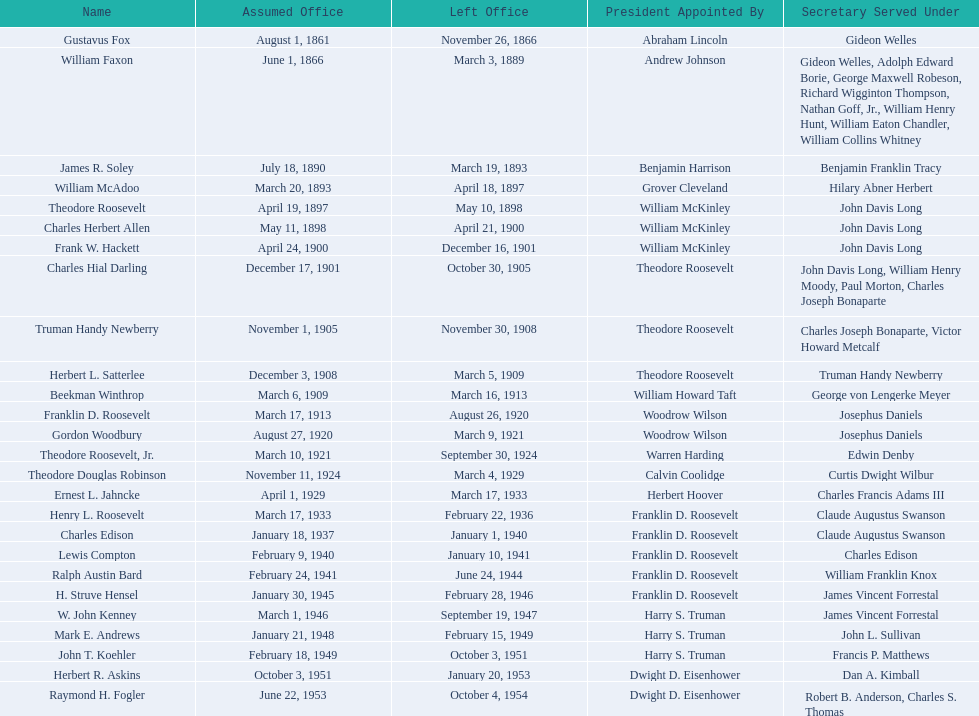Write the full table. {'header': ['Name', 'Assumed Office', 'Left Office', 'President Appointed By', 'Secretary Served Under'], 'rows': [['Gustavus Fox', 'August 1, 1861', 'November 26, 1866', 'Abraham Lincoln', 'Gideon Welles'], ['William Faxon', 'June 1, 1866', 'March 3, 1889', 'Andrew Johnson', 'Gideon Welles, Adolph Edward Borie, George Maxwell Robeson, Richard Wigginton Thompson, Nathan Goff, Jr., William Henry Hunt, William Eaton Chandler, William Collins Whitney'], ['James R. Soley', 'July 18, 1890', 'March 19, 1893', 'Benjamin Harrison', 'Benjamin Franklin Tracy'], ['William McAdoo', 'March 20, 1893', 'April 18, 1897', 'Grover Cleveland', 'Hilary Abner Herbert'], ['Theodore Roosevelt', 'April 19, 1897', 'May 10, 1898', 'William McKinley', 'John Davis Long'], ['Charles Herbert Allen', 'May 11, 1898', 'April 21, 1900', 'William McKinley', 'John Davis Long'], ['Frank W. Hackett', 'April 24, 1900', 'December 16, 1901', 'William McKinley', 'John Davis Long'], ['Charles Hial Darling', 'December 17, 1901', 'October 30, 1905', 'Theodore Roosevelt', 'John Davis Long, William Henry Moody, Paul Morton, Charles Joseph Bonaparte'], ['Truman Handy Newberry', 'November 1, 1905', 'November 30, 1908', 'Theodore Roosevelt', 'Charles Joseph Bonaparte, Victor Howard Metcalf'], ['Herbert L. Satterlee', 'December 3, 1908', 'March 5, 1909', 'Theodore Roosevelt', 'Truman Handy Newberry'], ['Beekman Winthrop', 'March 6, 1909', 'March 16, 1913', 'William Howard Taft', 'George von Lengerke Meyer'], ['Franklin D. Roosevelt', 'March 17, 1913', 'August 26, 1920', 'Woodrow Wilson', 'Josephus Daniels'], ['Gordon Woodbury', 'August 27, 1920', 'March 9, 1921', 'Woodrow Wilson', 'Josephus Daniels'], ['Theodore Roosevelt, Jr.', 'March 10, 1921', 'September 30, 1924', 'Warren Harding', 'Edwin Denby'], ['Theodore Douglas Robinson', 'November 11, 1924', 'March 4, 1929', 'Calvin Coolidge', 'Curtis Dwight Wilbur'], ['Ernest L. Jahncke', 'April 1, 1929', 'March 17, 1933', 'Herbert Hoover', 'Charles Francis Adams III'], ['Henry L. Roosevelt', 'March 17, 1933', 'February 22, 1936', 'Franklin D. Roosevelt', 'Claude Augustus Swanson'], ['Charles Edison', 'January 18, 1937', 'January 1, 1940', 'Franklin D. Roosevelt', 'Claude Augustus Swanson'], ['Lewis Compton', 'February 9, 1940', 'January 10, 1941', 'Franklin D. Roosevelt', 'Charles Edison'], ['Ralph Austin Bard', 'February 24, 1941', 'June 24, 1944', 'Franklin D. Roosevelt', 'William Franklin Knox'], ['H. Struve Hensel', 'January 30, 1945', 'February 28, 1946', 'Franklin D. Roosevelt', 'James Vincent Forrestal'], ['W. John Kenney', 'March 1, 1946', 'September 19, 1947', 'Harry S. Truman', 'James Vincent Forrestal'], ['Mark E. Andrews', 'January 21, 1948', 'February 15, 1949', 'Harry S. Truman', 'John L. Sullivan'], ['John T. Koehler', 'February 18, 1949', 'October 3, 1951', 'Harry S. Truman', 'Francis P. Matthews'], ['Herbert R. Askins', 'October 3, 1951', 'January 20, 1953', 'Dwight D. Eisenhower', 'Dan A. Kimball'], ['Raymond H. Fogler', 'June 22, 1953', 'October 4, 1954', 'Dwight D. Eisenhower', 'Robert B. Anderson, Charles S. Thomas']]} Who are all of the assistant secretaries of the navy in the 20th century? Charles Herbert Allen, Frank W. Hackett, Charles Hial Darling, Truman Handy Newberry, Herbert L. Satterlee, Beekman Winthrop, Franklin D. Roosevelt, Gordon Woodbury, Theodore Roosevelt, Jr., Theodore Douglas Robinson, Ernest L. Jahncke, Henry L. Roosevelt, Charles Edison, Lewis Compton, Ralph Austin Bard, H. Struve Hensel, W. John Kenney, Mark E. Andrews, John T. Koehler, Herbert R. Askins, Raymond H. Fogler. What date was assistant secretary of the navy raymond h. fogler appointed? June 22, 1953. What date did assistant secretary of the navy raymond h. fogler leave office? October 4, 1954. 